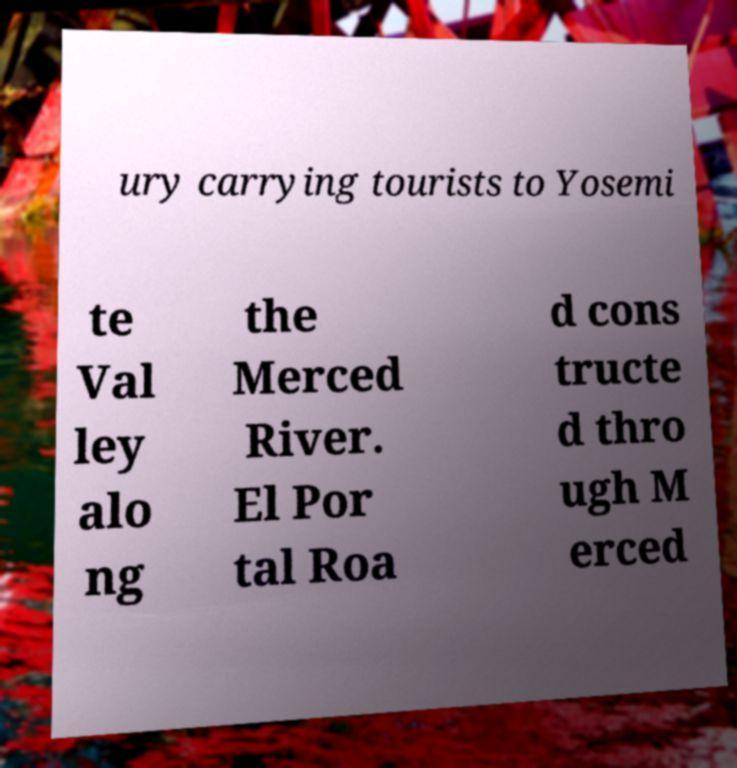Can you accurately transcribe the text from the provided image for me? ury carrying tourists to Yosemi te Val ley alo ng the Merced River. El Por tal Roa d cons tructe d thro ugh M erced 